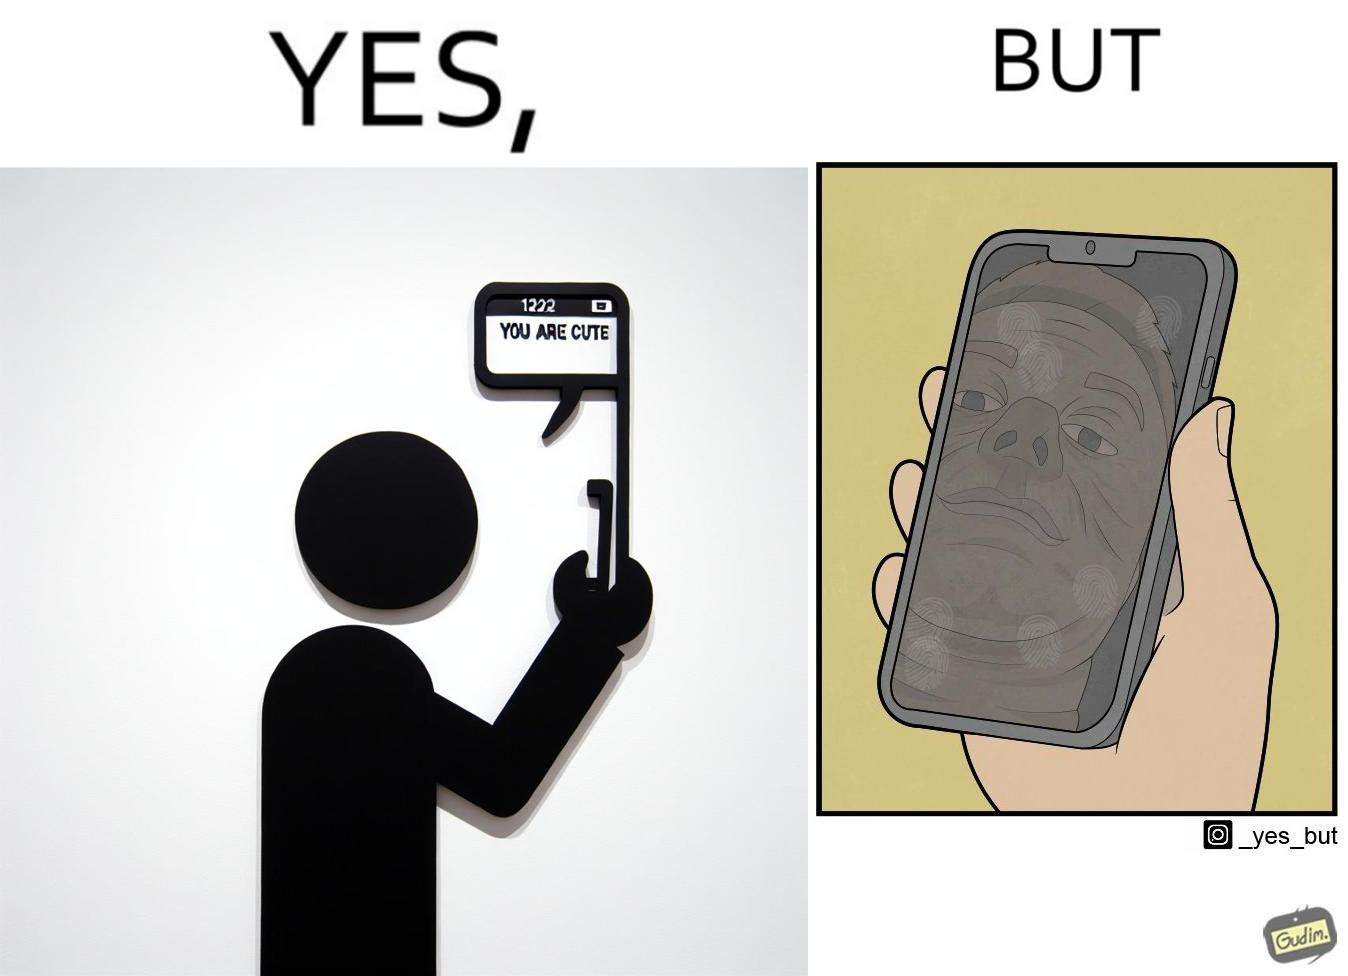What makes this image funny or satirical? The image is ironic, because person who received the text saying "you are cute" is apparently not good looking according to the beautyÃÂ standards 